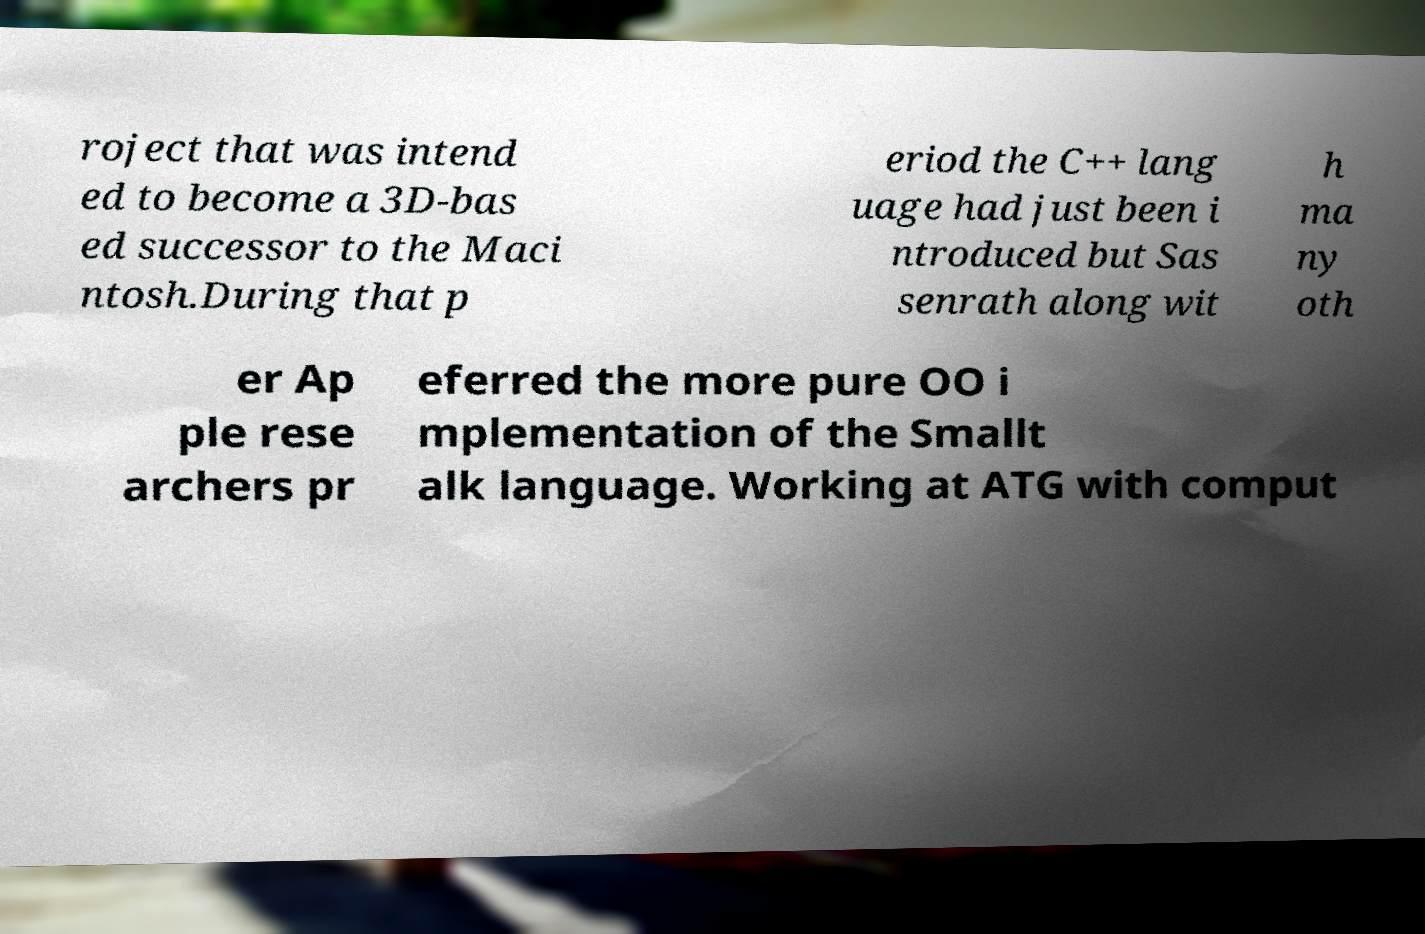Can you read and provide the text displayed in the image?This photo seems to have some interesting text. Can you extract and type it out for me? roject that was intend ed to become a 3D-bas ed successor to the Maci ntosh.During that p eriod the C++ lang uage had just been i ntroduced but Sas senrath along wit h ma ny oth er Ap ple rese archers pr eferred the more pure OO i mplementation of the Smallt alk language. Working at ATG with comput 